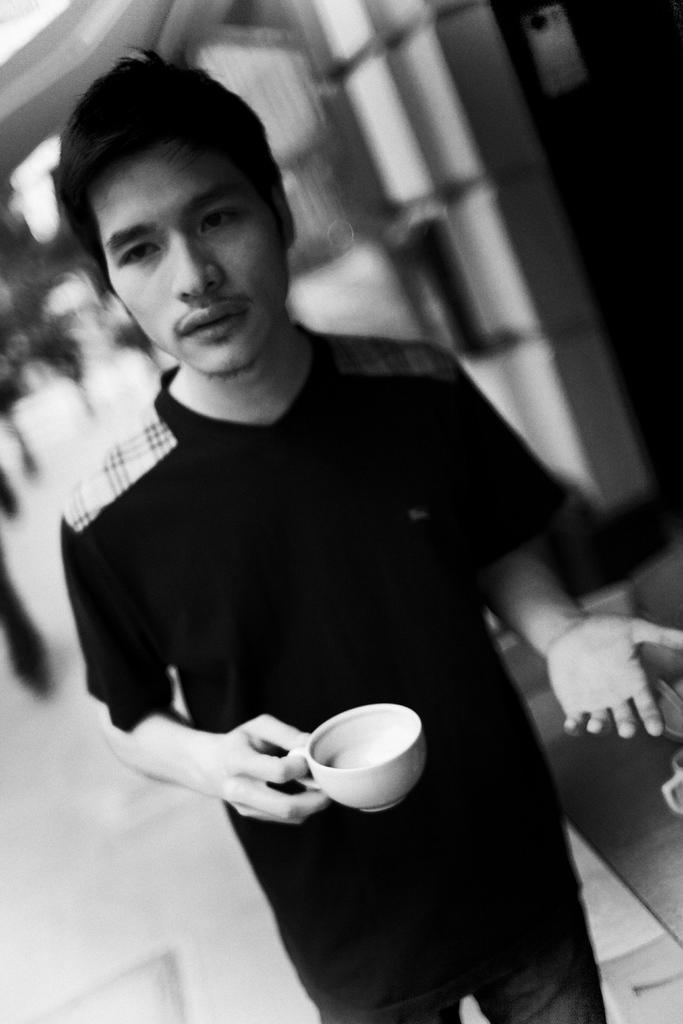What is present in the image? There is a person in the image. What is the person holding in his right hand? The person is holding a cup in his right hand. What is the person wearing? The person is wearing a black shirt. How many chairs are visible in the image? There are no chairs visible in the image; it only features a person holding a cup and wearing a black shirt. 